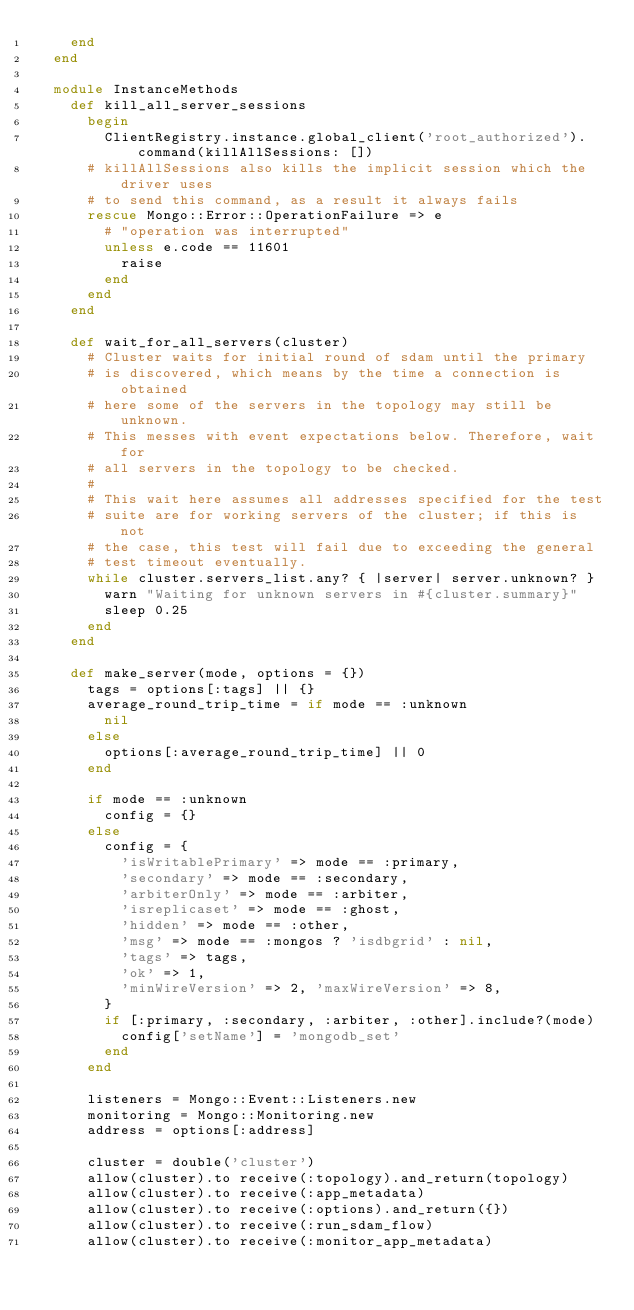Convert code to text. <code><loc_0><loc_0><loc_500><loc_500><_Ruby_>    end
  end

  module InstanceMethods
    def kill_all_server_sessions
      begin
        ClientRegistry.instance.global_client('root_authorized').command(killAllSessions: [])
      # killAllSessions also kills the implicit session which the driver uses
      # to send this command, as a result it always fails
      rescue Mongo::Error::OperationFailure => e
        # "operation was interrupted"
        unless e.code == 11601
          raise
        end
      end
    end

    def wait_for_all_servers(cluster)
      # Cluster waits for initial round of sdam until the primary
      # is discovered, which means by the time a connection is obtained
      # here some of the servers in the topology may still be unknown.
      # This messes with event expectations below. Therefore, wait for
      # all servers in the topology to be checked.
      #
      # This wait here assumes all addresses specified for the test
      # suite are for working servers of the cluster; if this is not
      # the case, this test will fail due to exceeding the general
      # test timeout eventually.
      while cluster.servers_list.any? { |server| server.unknown? }
        warn "Waiting for unknown servers in #{cluster.summary}"
        sleep 0.25
      end
    end

    def make_server(mode, options = {})
      tags = options[:tags] || {}
      average_round_trip_time = if mode == :unknown
        nil
      else
        options[:average_round_trip_time] || 0
      end

      if mode == :unknown
        config = {}
      else
        config = {
          'isWritablePrimary' => mode == :primary,
          'secondary' => mode == :secondary,
          'arbiterOnly' => mode == :arbiter,
          'isreplicaset' => mode == :ghost,
          'hidden' => mode == :other,
          'msg' => mode == :mongos ? 'isdbgrid' : nil,
          'tags' => tags,
          'ok' => 1,
          'minWireVersion' => 2, 'maxWireVersion' => 8,
        }
        if [:primary, :secondary, :arbiter, :other].include?(mode)
          config['setName'] = 'mongodb_set'
        end
      end

      listeners = Mongo::Event::Listeners.new
      monitoring = Mongo::Monitoring.new
      address = options[:address]

      cluster = double('cluster')
      allow(cluster).to receive(:topology).and_return(topology)
      allow(cluster).to receive(:app_metadata)
      allow(cluster).to receive(:options).and_return({})
      allow(cluster).to receive(:run_sdam_flow)
      allow(cluster).to receive(:monitor_app_metadata)</code> 